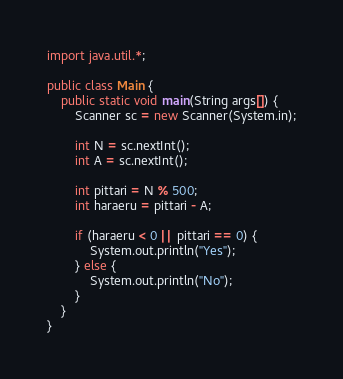<code> <loc_0><loc_0><loc_500><loc_500><_Java_>import java.util.*;

public class Main {
    public static void main(String args[]) {
        Scanner sc = new Scanner(System.in);

        int N = sc.nextInt();
        int A = sc.nextInt();

        int pittari = N % 500;
        int haraeru = pittari - A;
        
        if (haraeru < 0 || pittari == 0) {
            System.out.println("Yes");
        } else {
            System.out.println("No");
        }
    }
}</code> 